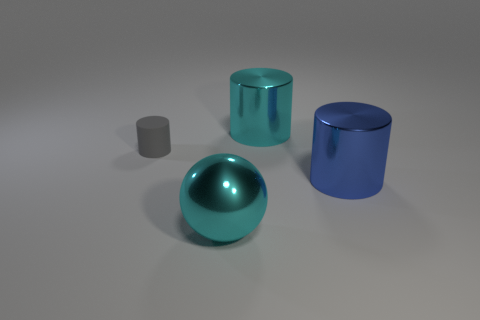Are there an equal number of shiny cylinders behind the cyan shiny ball and large cyan metallic objects in front of the large blue shiny object?
Make the answer very short. No. There is a blue shiny object that is the same shape as the small gray rubber thing; what size is it?
Ensure brevity in your answer.  Large. What size is the thing that is behind the cyan ball and to the left of the cyan shiny cylinder?
Provide a short and direct response. Small. Are there any blue metal cylinders to the right of the blue shiny object?
Provide a short and direct response. No. What number of objects are either large metal things that are behind the small gray matte cylinder or large cyan things?
Your answer should be very brief. 2. What number of small gray rubber cylinders are right of the large cyan object that is behind the gray cylinder?
Your response must be concise. 0. Are there fewer large cyan spheres on the right side of the big blue metallic cylinder than small gray matte objects that are to the right of the rubber cylinder?
Offer a very short reply. No. What is the shape of the big shiny object right of the big cyan metal thing on the right side of the cyan ball?
Provide a short and direct response. Cylinder. How many other objects are there of the same material as the large blue cylinder?
Your response must be concise. 2. Are there any other things that have the same size as the blue metal cylinder?
Your answer should be compact. Yes. 